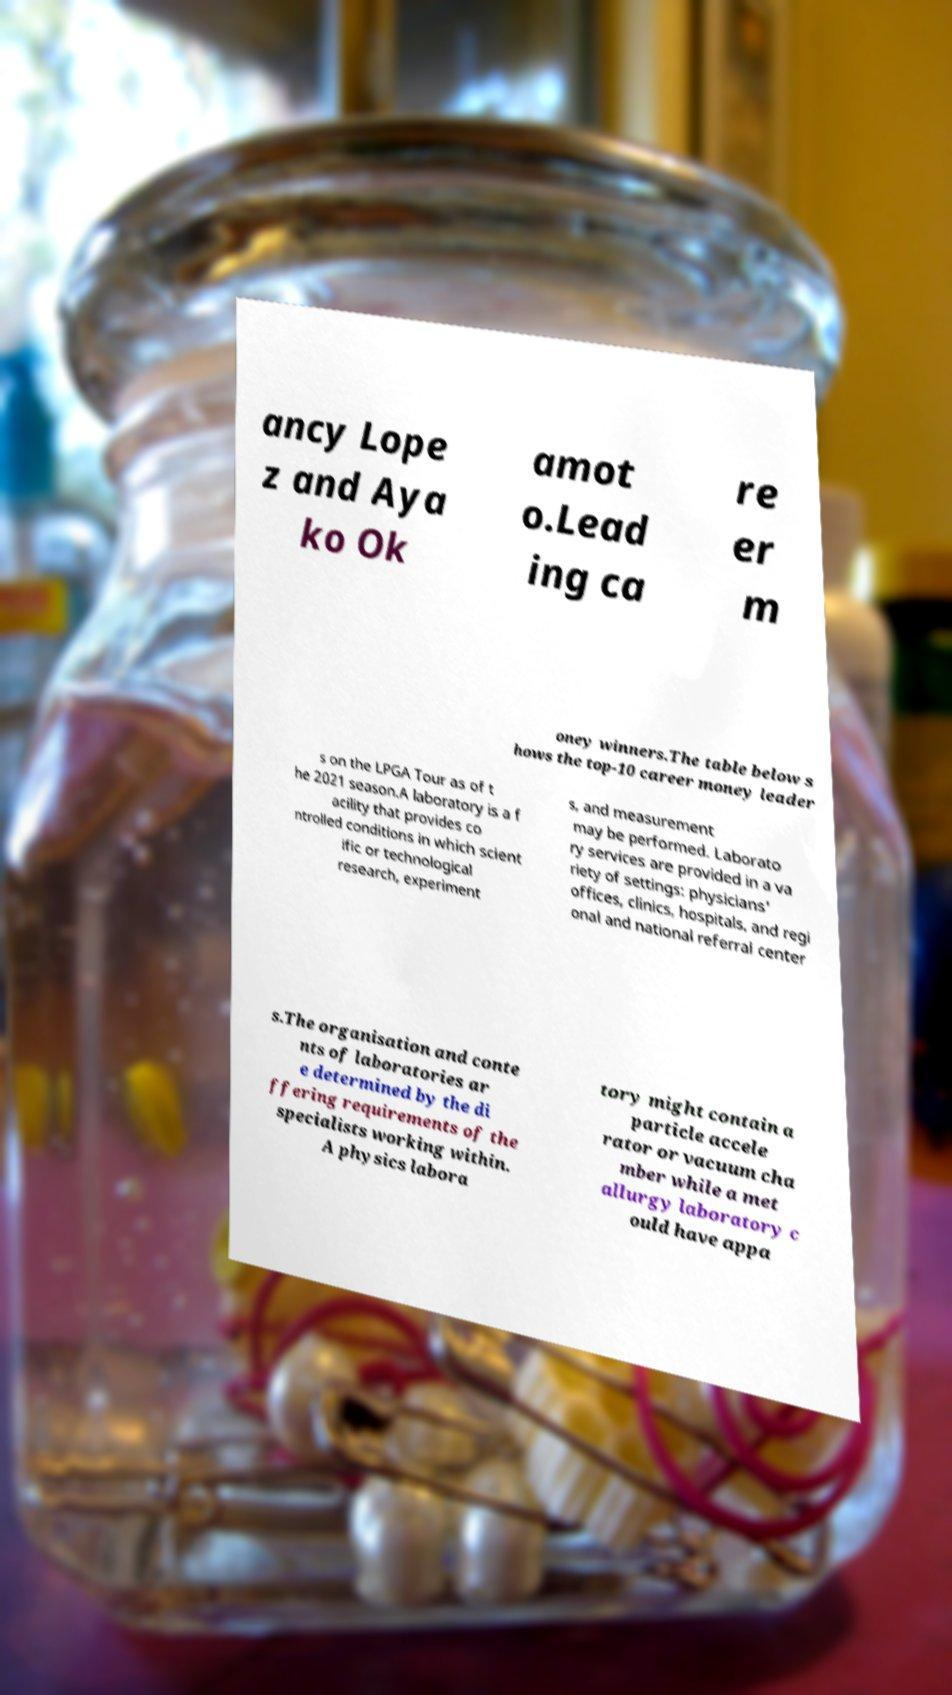Please identify and transcribe the text found in this image. ancy Lope z and Aya ko Ok amot o.Lead ing ca re er m oney winners.The table below s hows the top-10 career money leader s on the LPGA Tour as of t he 2021 season.A laboratory is a f acility that provides co ntrolled conditions in which scient ific or technological research, experiment s, and measurement may be performed. Laborato ry services are provided in a va riety of settings: physicians' offices, clinics, hospitals, and regi onal and national referral center s.The organisation and conte nts of laboratories ar e determined by the di ffering requirements of the specialists working within. A physics labora tory might contain a particle accele rator or vacuum cha mber while a met allurgy laboratory c ould have appa 